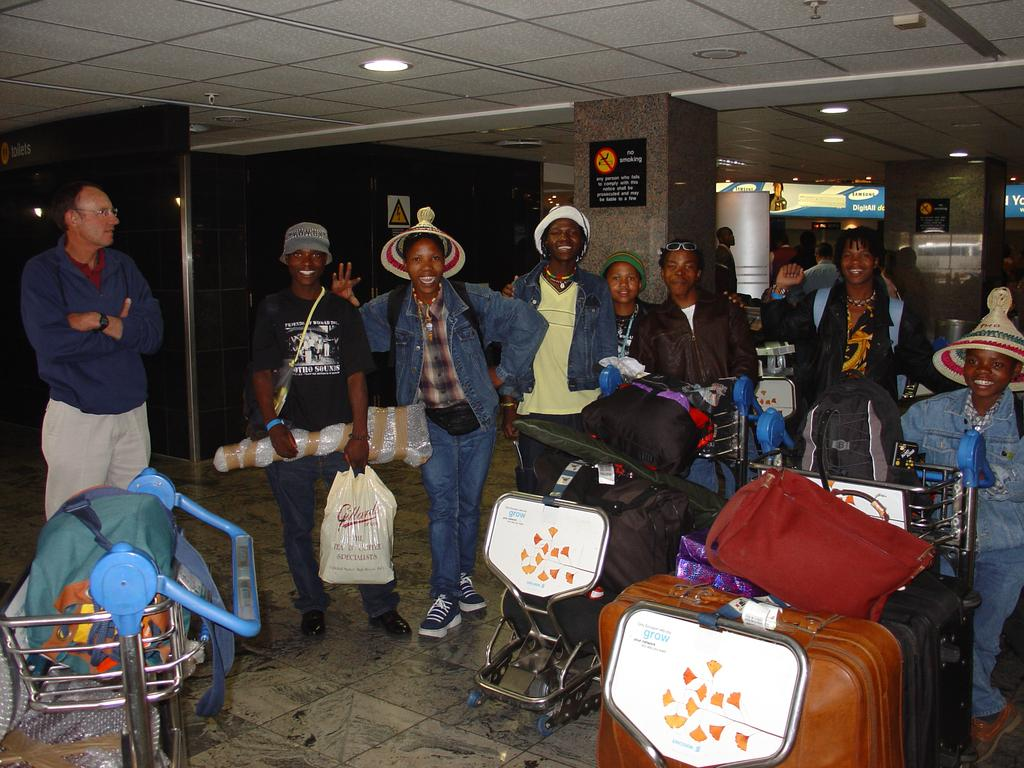What is happening in the image involving a group of people? There is a group of people in the image, and they are standing on the road. What are the people carrying in the image? The people are carrying bags in the image. Are there any bags on the ground in the image? Yes, there are bags on the floor in the image. What type of oatmeal is being served to the farmer in the image? There is no farmer or oatmeal present in the image. Can you describe the bird that is flying over the group of people in the image? There is no bird present in the image. 